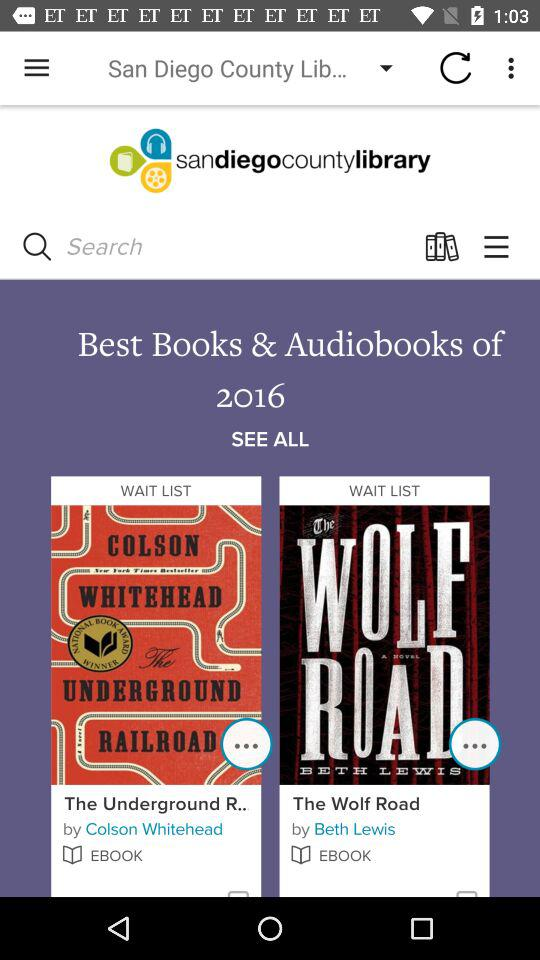What is the name of the ebook written by Colson Whitehead? The name of the ebook is "The Underground R..". 